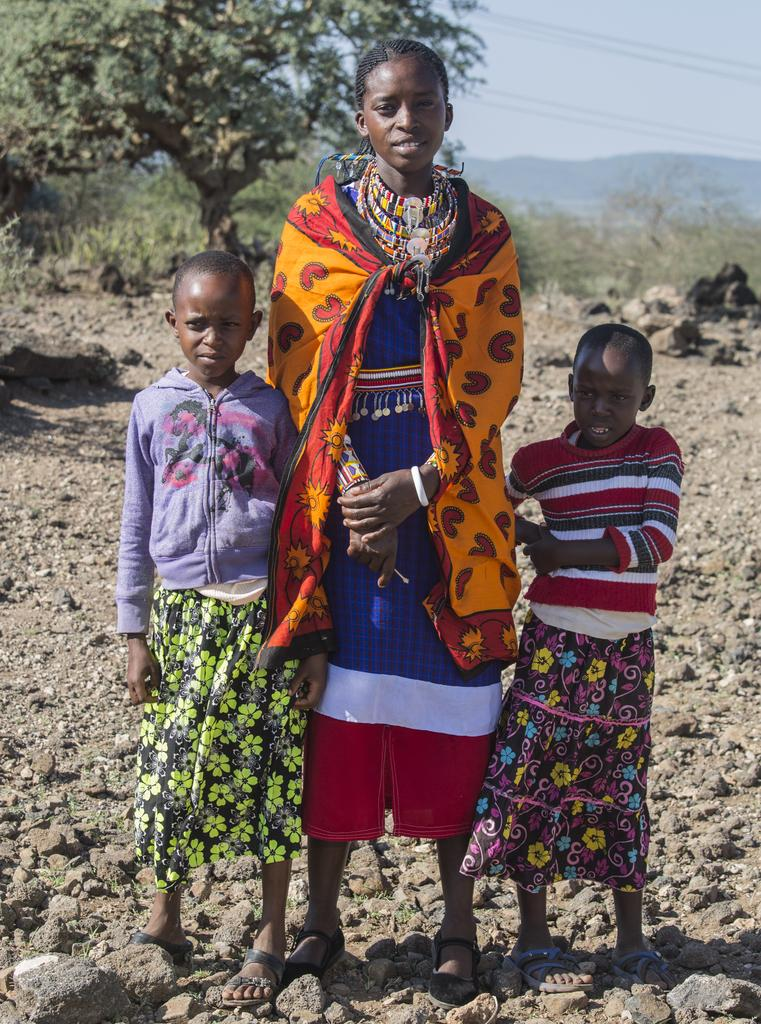What are the people in the image doing? The persons standing on the ground in the image are likely standing or walking. What can be seen in the background of the image? There are trees, stones, a hill, and the sky visible in the background of the image. How many different types of natural elements can be seen in the background? There are four different types of natural elements in the background: trees, stones, a hill, and the sky. What type of plant is growing on the hill in the image? There is no plant growing on the hill in the image; only trees, stones, and the sky are visible in the background. 